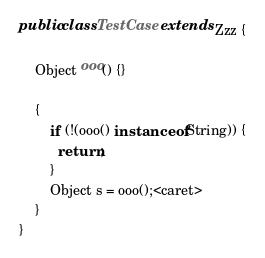<code> <loc_0><loc_0><loc_500><loc_500><_Java_>public class TestCase extends Zzz {

    Object ooo() {}

    {
        if (!(ooo() instanceof String)) {
          return;
        }
        Object s = ooo();<caret>
    }
}</code> 